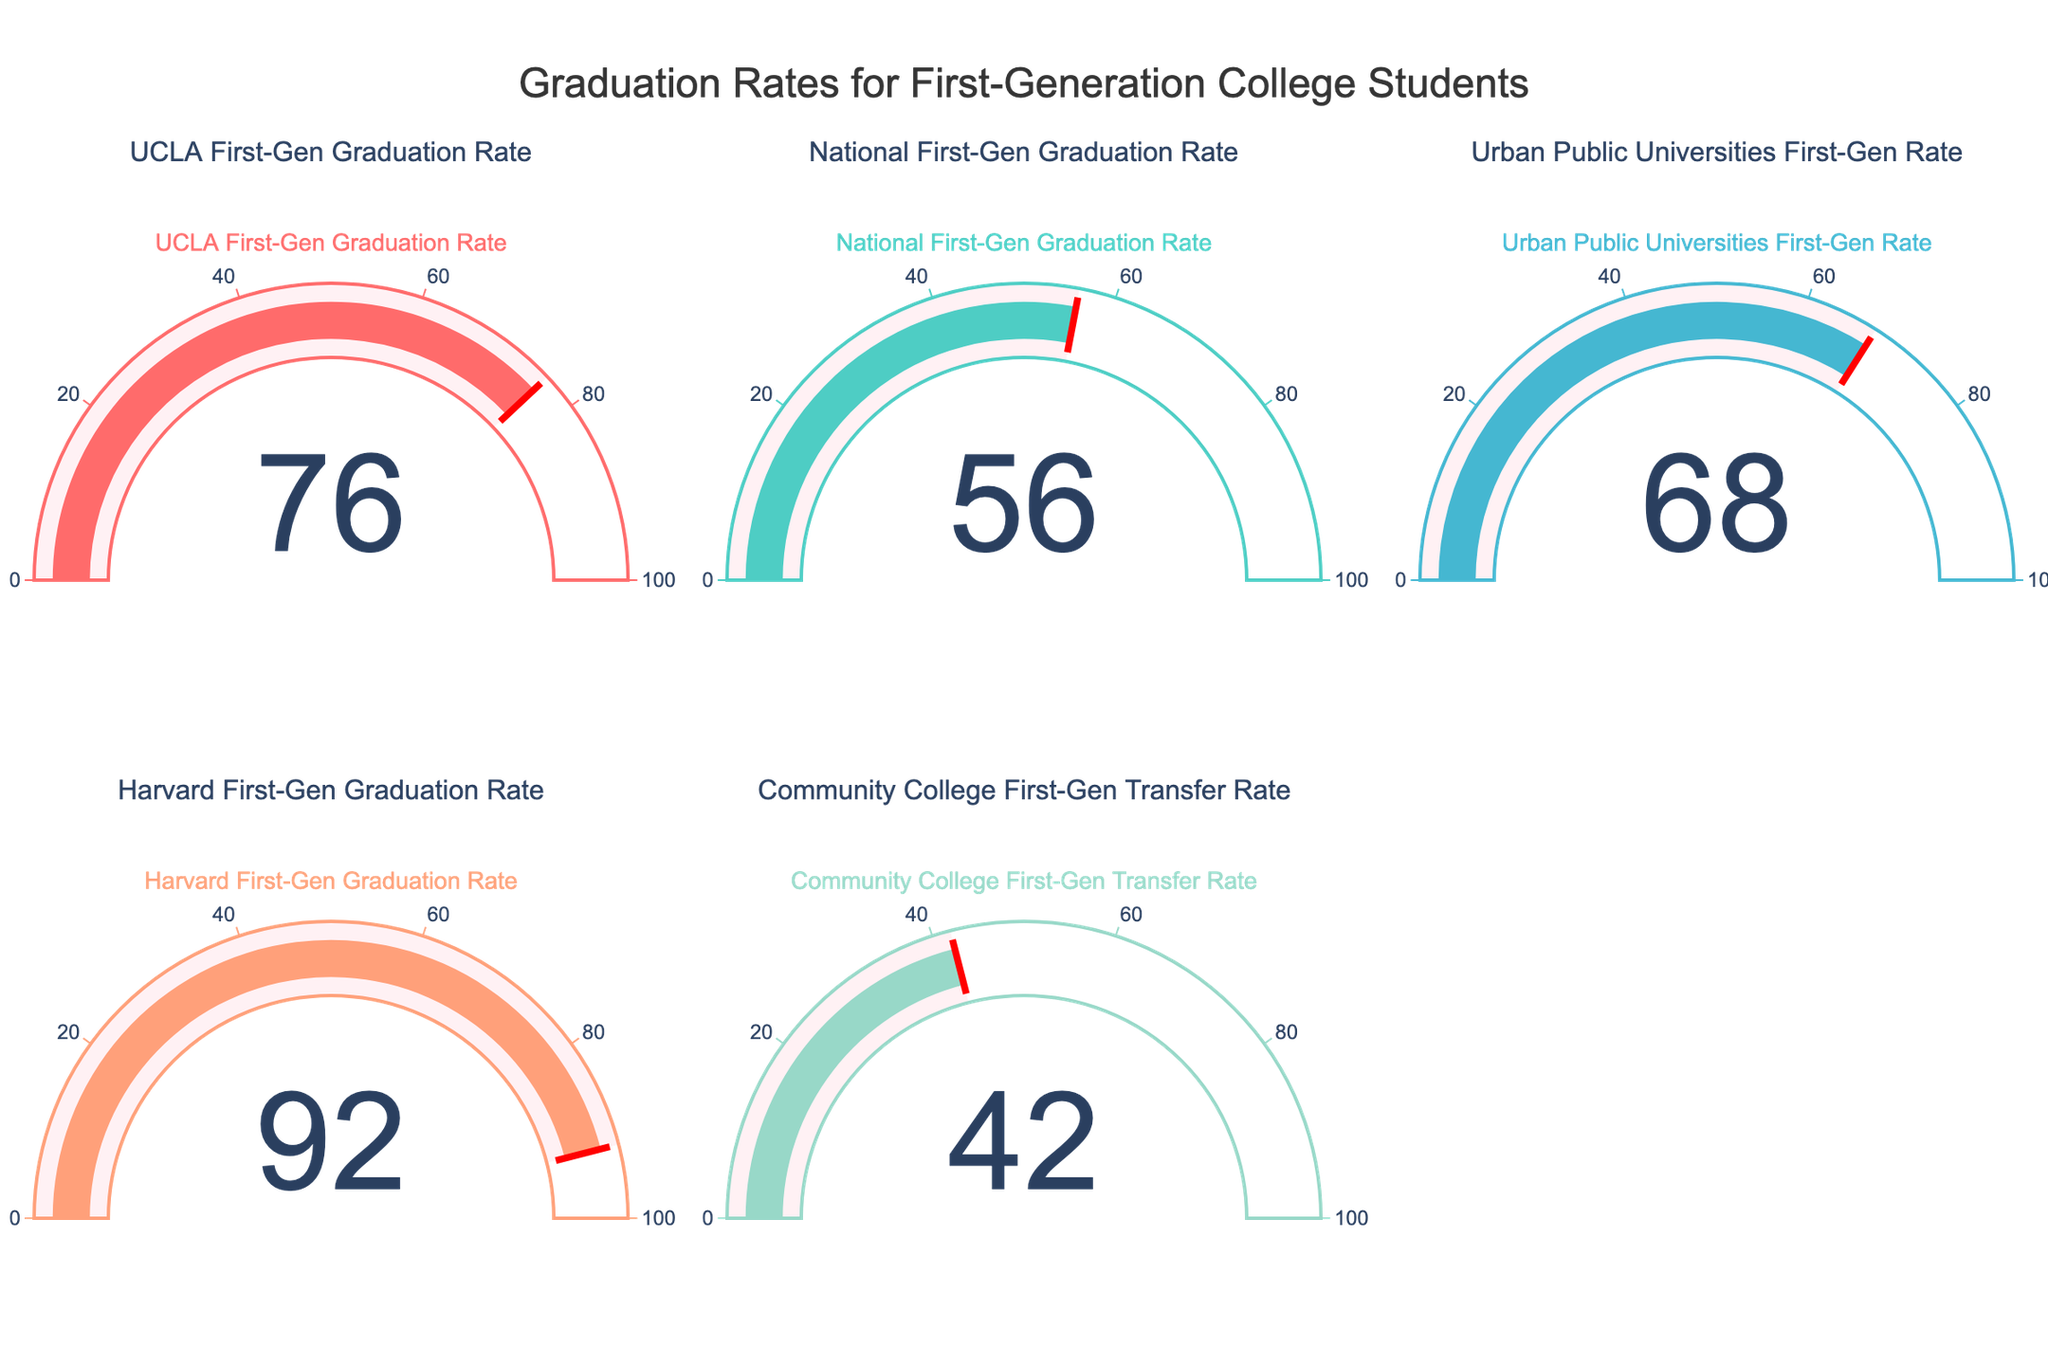What's the highest graduation rate among first-gen students? By looking at the highest number displayed on the gauges, we see that Harvard First-Gen Graduation Rate is 92, which is the highest among the listed data points.
Answer: 92 How does the UCLA First-Gen Graduation Rate compare to the National First-Gen Graduation Rate? UCLA has a rate of 76, while the national rate is 56. Since 76 is greater than 56, UCLA's rate is higher.
Answer: UCLA's rate is higher What's the difference between the Urban Public Universities First-Gen Rate and the Community College First-Gen Transfer Rate? From the gauge charts, we see Urban Public Universities First-Gen Rate is 68 and Community College First-Gen Transfer Rate is 42. The difference is 68 - 42 = 26.
Answer: 26 What percentage is the Community College First-Gen Transfer Rate compared to the National First-Gen Graduation Rate? Community College rate is 42 and National rate is 56. To find the percentage, divide 42 by 56 and multiply by 100: (42/56)*100 ≈ 75%.
Answer: ≈75% Which institution has the lowest first-gen graduation rate? By looking at the gauge charts, the Community College First-Gen Transfer Rate is 42, which is the lowest among the listed data points.
Answer: Community College Among the listed rates, how many have graduation rates above 70? By examining the gauges, UCLA (76), Urban Public Universities (68), Harvard (92), and National (56), only UCLA and Harvard have rates above 70.
Answer: Two How much higher is Harvard's First-Gen Graduation Rate compared to the Urban Public Universities First-Gen Rate? Harvard's rate is 92 and Urban Public Universities' rate is 68. The difference is 92 - 68 = 24.
Answer: 24 If you were to average the graduation rates of all listed institutions (including the transfer rate), what would that rate be? Summing the rates: 76 + 56 + 68 + 92 + 42 = 334. There are 5 rates, so the average is 334/5 = 66.8.
Answer: 66.8 